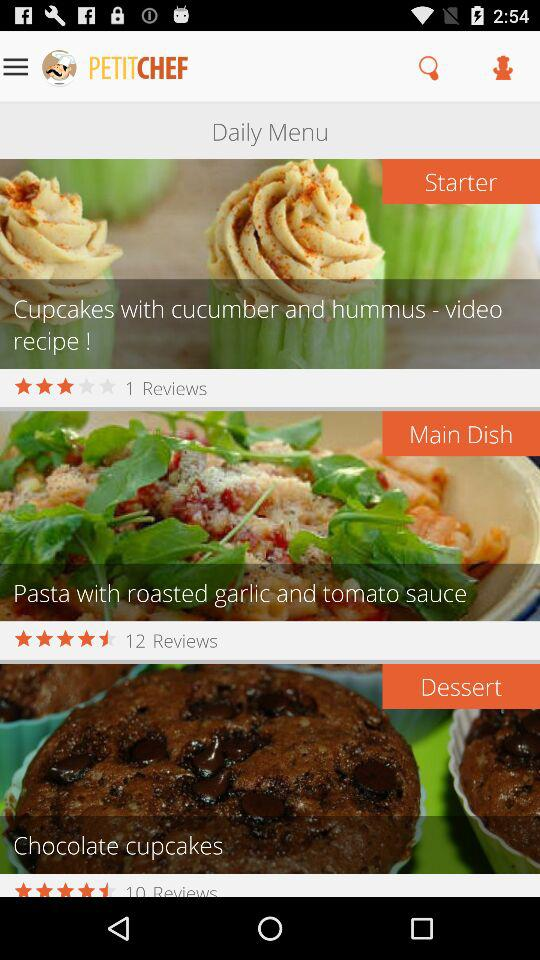What is the given star rating for the main dish? The given star rating for the main dish is 4.5. 